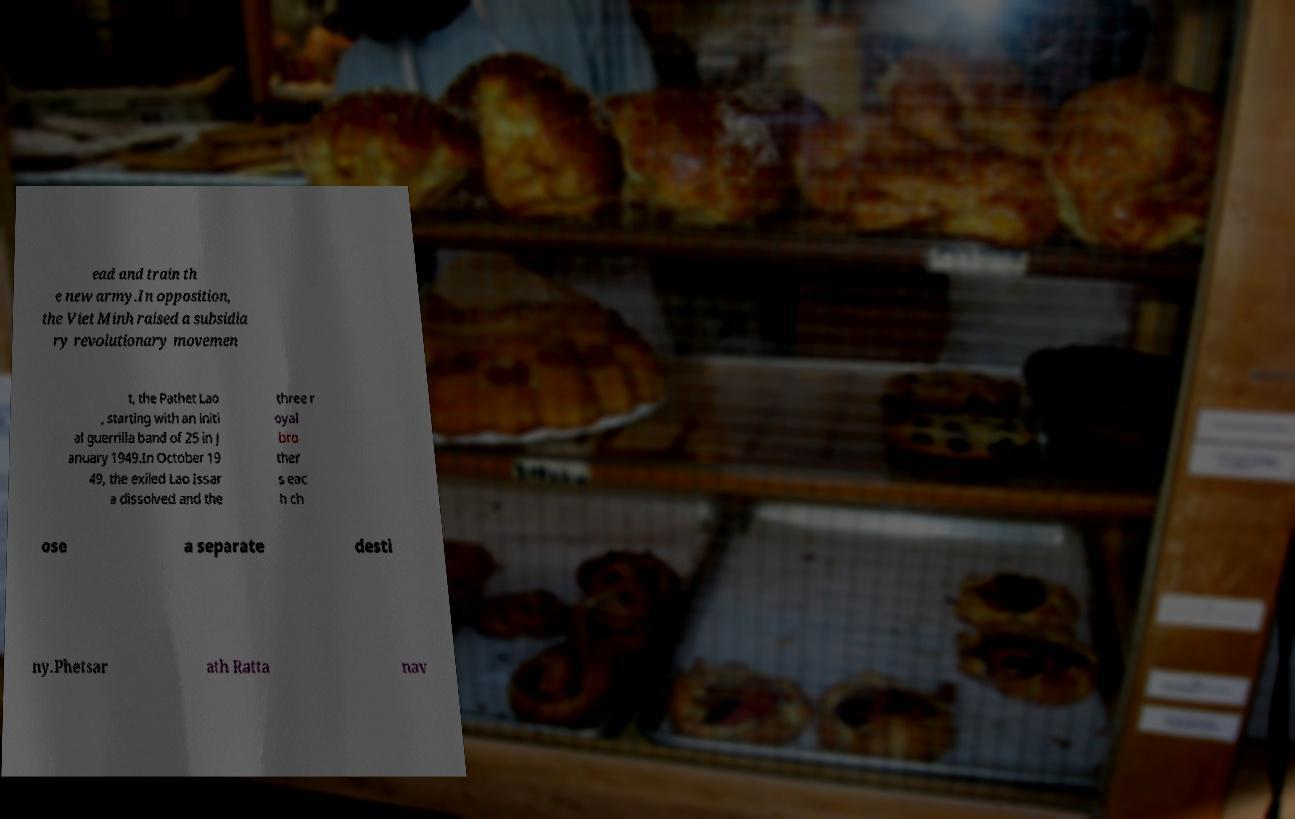What messages or text are displayed in this image? I need them in a readable, typed format. ead and train th e new army.In opposition, the Viet Minh raised a subsidia ry revolutionary movemen t, the Pathet Lao , starting with an initi al guerrilla band of 25 in J anuary 1949.In October 19 49, the exiled Lao Issar a dissolved and the three r oyal bro ther s eac h ch ose a separate desti ny.Phetsar ath Ratta nav 